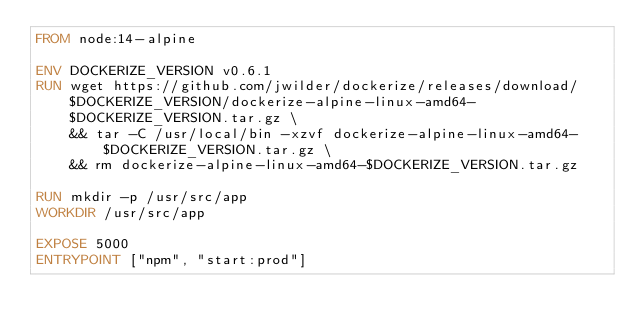<code> <loc_0><loc_0><loc_500><loc_500><_Dockerfile_>FROM node:14-alpine

ENV DOCKERIZE_VERSION v0.6.1
RUN wget https://github.com/jwilder/dockerize/releases/download/$DOCKERIZE_VERSION/dockerize-alpine-linux-amd64-$DOCKERIZE_VERSION.tar.gz \
    && tar -C /usr/local/bin -xzvf dockerize-alpine-linux-amd64-$DOCKERIZE_VERSION.tar.gz \
    && rm dockerize-alpine-linux-amd64-$DOCKERIZE_VERSION.tar.gz

RUN mkdir -p /usr/src/app
WORKDIR /usr/src/app

EXPOSE 5000
ENTRYPOINT ["npm", "start:prod"]
</code> 